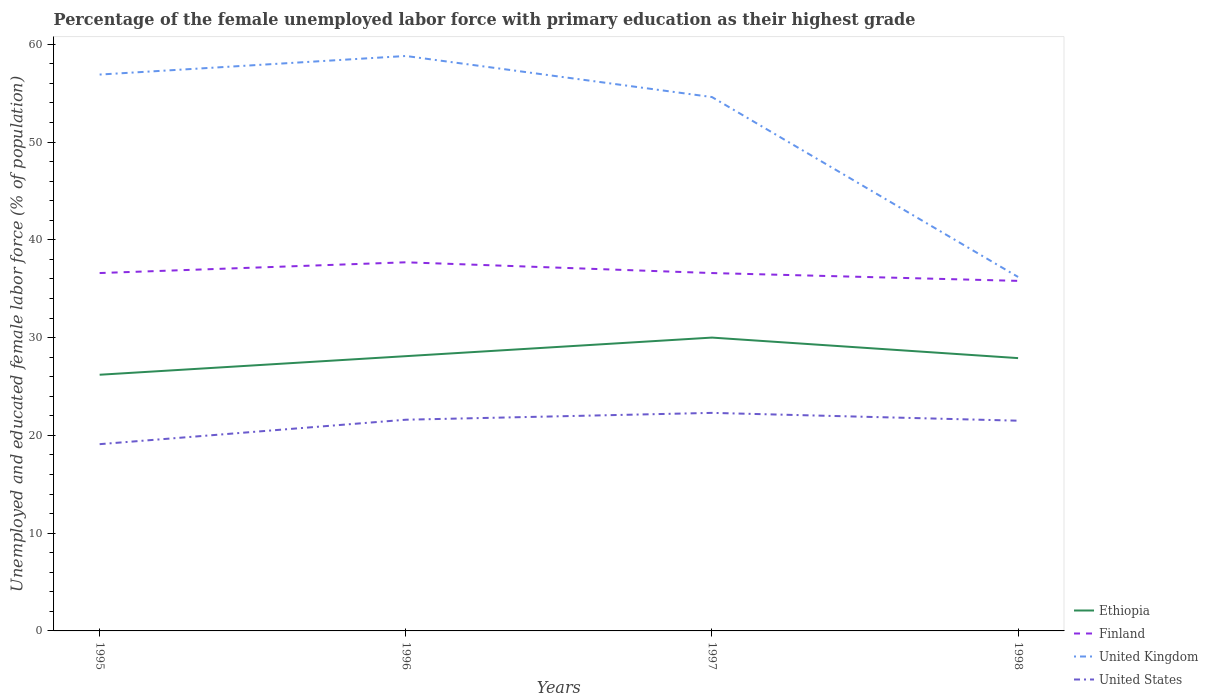How many different coloured lines are there?
Offer a terse response. 4. Across all years, what is the maximum percentage of the unemployed female labor force with primary education in Ethiopia?
Provide a succinct answer. 26.2. In which year was the percentage of the unemployed female labor force with primary education in United States maximum?
Your response must be concise. 1995. What is the total percentage of the unemployed female labor force with primary education in Ethiopia in the graph?
Ensure brevity in your answer.  2.1. What is the difference between the highest and the second highest percentage of the unemployed female labor force with primary education in Ethiopia?
Your answer should be compact. 3.8. What is the difference between the highest and the lowest percentage of the unemployed female labor force with primary education in United Kingdom?
Provide a short and direct response. 3. How many years are there in the graph?
Your response must be concise. 4. What is the difference between two consecutive major ticks on the Y-axis?
Your response must be concise. 10. Does the graph contain any zero values?
Provide a short and direct response. No. Where does the legend appear in the graph?
Offer a terse response. Bottom right. How many legend labels are there?
Offer a very short reply. 4. How are the legend labels stacked?
Your answer should be compact. Vertical. What is the title of the graph?
Offer a very short reply. Percentage of the female unemployed labor force with primary education as their highest grade. Does "Marshall Islands" appear as one of the legend labels in the graph?
Provide a succinct answer. No. What is the label or title of the Y-axis?
Make the answer very short. Unemployed and educated female labor force (% of population). What is the Unemployed and educated female labor force (% of population) of Ethiopia in 1995?
Keep it short and to the point. 26.2. What is the Unemployed and educated female labor force (% of population) in Finland in 1995?
Provide a succinct answer. 36.6. What is the Unemployed and educated female labor force (% of population) in United Kingdom in 1995?
Your answer should be compact. 56.9. What is the Unemployed and educated female labor force (% of population) of United States in 1995?
Give a very brief answer. 19.1. What is the Unemployed and educated female labor force (% of population) of Ethiopia in 1996?
Your response must be concise. 28.1. What is the Unemployed and educated female labor force (% of population) in Finland in 1996?
Provide a succinct answer. 37.7. What is the Unemployed and educated female labor force (% of population) of United Kingdom in 1996?
Make the answer very short. 58.8. What is the Unemployed and educated female labor force (% of population) in United States in 1996?
Make the answer very short. 21.6. What is the Unemployed and educated female labor force (% of population) of Ethiopia in 1997?
Keep it short and to the point. 30. What is the Unemployed and educated female labor force (% of population) in Finland in 1997?
Your answer should be compact. 36.6. What is the Unemployed and educated female labor force (% of population) in United Kingdom in 1997?
Your response must be concise. 54.6. What is the Unemployed and educated female labor force (% of population) of United States in 1997?
Your answer should be very brief. 22.3. What is the Unemployed and educated female labor force (% of population) in Ethiopia in 1998?
Offer a terse response. 27.9. What is the Unemployed and educated female labor force (% of population) in Finland in 1998?
Offer a terse response. 35.8. What is the Unemployed and educated female labor force (% of population) of United Kingdom in 1998?
Your response must be concise. 36.2. What is the Unemployed and educated female labor force (% of population) in United States in 1998?
Your answer should be very brief. 21.5. Across all years, what is the maximum Unemployed and educated female labor force (% of population) of Finland?
Your response must be concise. 37.7. Across all years, what is the maximum Unemployed and educated female labor force (% of population) in United Kingdom?
Provide a succinct answer. 58.8. Across all years, what is the maximum Unemployed and educated female labor force (% of population) of United States?
Offer a very short reply. 22.3. Across all years, what is the minimum Unemployed and educated female labor force (% of population) of Ethiopia?
Make the answer very short. 26.2. Across all years, what is the minimum Unemployed and educated female labor force (% of population) in Finland?
Offer a terse response. 35.8. Across all years, what is the minimum Unemployed and educated female labor force (% of population) in United Kingdom?
Provide a short and direct response. 36.2. Across all years, what is the minimum Unemployed and educated female labor force (% of population) of United States?
Offer a terse response. 19.1. What is the total Unemployed and educated female labor force (% of population) in Ethiopia in the graph?
Your answer should be very brief. 112.2. What is the total Unemployed and educated female labor force (% of population) in Finland in the graph?
Keep it short and to the point. 146.7. What is the total Unemployed and educated female labor force (% of population) in United Kingdom in the graph?
Offer a terse response. 206.5. What is the total Unemployed and educated female labor force (% of population) in United States in the graph?
Offer a very short reply. 84.5. What is the difference between the Unemployed and educated female labor force (% of population) in Ethiopia in 1995 and that in 1996?
Give a very brief answer. -1.9. What is the difference between the Unemployed and educated female labor force (% of population) of United Kingdom in 1995 and that in 1997?
Offer a terse response. 2.3. What is the difference between the Unemployed and educated female labor force (% of population) in Ethiopia in 1995 and that in 1998?
Offer a terse response. -1.7. What is the difference between the Unemployed and educated female labor force (% of population) in United Kingdom in 1995 and that in 1998?
Offer a very short reply. 20.7. What is the difference between the Unemployed and educated female labor force (% of population) of Ethiopia in 1996 and that in 1997?
Your answer should be compact. -1.9. What is the difference between the Unemployed and educated female labor force (% of population) in United Kingdom in 1996 and that in 1997?
Make the answer very short. 4.2. What is the difference between the Unemployed and educated female labor force (% of population) in Ethiopia in 1996 and that in 1998?
Your response must be concise. 0.2. What is the difference between the Unemployed and educated female labor force (% of population) of United Kingdom in 1996 and that in 1998?
Your response must be concise. 22.6. What is the difference between the Unemployed and educated female labor force (% of population) of United States in 1996 and that in 1998?
Give a very brief answer. 0.1. What is the difference between the Unemployed and educated female labor force (% of population) in Ethiopia in 1997 and that in 1998?
Offer a very short reply. 2.1. What is the difference between the Unemployed and educated female labor force (% of population) of United States in 1997 and that in 1998?
Ensure brevity in your answer.  0.8. What is the difference between the Unemployed and educated female labor force (% of population) in Ethiopia in 1995 and the Unemployed and educated female labor force (% of population) in Finland in 1996?
Provide a short and direct response. -11.5. What is the difference between the Unemployed and educated female labor force (% of population) in Ethiopia in 1995 and the Unemployed and educated female labor force (% of population) in United Kingdom in 1996?
Ensure brevity in your answer.  -32.6. What is the difference between the Unemployed and educated female labor force (% of population) of Finland in 1995 and the Unemployed and educated female labor force (% of population) of United Kingdom in 1996?
Your answer should be compact. -22.2. What is the difference between the Unemployed and educated female labor force (% of population) in United Kingdom in 1995 and the Unemployed and educated female labor force (% of population) in United States in 1996?
Keep it short and to the point. 35.3. What is the difference between the Unemployed and educated female labor force (% of population) in Ethiopia in 1995 and the Unemployed and educated female labor force (% of population) in Finland in 1997?
Give a very brief answer. -10.4. What is the difference between the Unemployed and educated female labor force (% of population) of Ethiopia in 1995 and the Unemployed and educated female labor force (% of population) of United Kingdom in 1997?
Your response must be concise. -28.4. What is the difference between the Unemployed and educated female labor force (% of population) of Ethiopia in 1995 and the Unemployed and educated female labor force (% of population) of United States in 1997?
Keep it short and to the point. 3.9. What is the difference between the Unemployed and educated female labor force (% of population) in Finland in 1995 and the Unemployed and educated female labor force (% of population) in United Kingdom in 1997?
Your response must be concise. -18. What is the difference between the Unemployed and educated female labor force (% of population) of United Kingdom in 1995 and the Unemployed and educated female labor force (% of population) of United States in 1997?
Provide a short and direct response. 34.6. What is the difference between the Unemployed and educated female labor force (% of population) of Ethiopia in 1995 and the Unemployed and educated female labor force (% of population) of Finland in 1998?
Ensure brevity in your answer.  -9.6. What is the difference between the Unemployed and educated female labor force (% of population) in Ethiopia in 1995 and the Unemployed and educated female labor force (% of population) in United Kingdom in 1998?
Offer a very short reply. -10. What is the difference between the Unemployed and educated female labor force (% of population) of Ethiopia in 1995 and the Unemployed and educated female labor force (% of population) of United States in 1998?
Offer a very short reply. 4.7. What is the difference between the Unemployed and educated female labor force (% of population) in Finland in 1995 and the Unemployed and educated female labor force (% of population) in United States in 1998?
Provide a succinct answer. 15.1. What is the difference between the Unemployed and educated female labor force (% of population) of United Kingdom in 1995 and the Unemployed and educated female labor force (% of population) of United States in 1998?
Offer a very short reply. 35.4. What is the difference between the Unemployed and educated female labor force (% of population) in Ethiopia in 1996 and the Unemployed and educated female labor force (% of population) in Finland in 1997?
Offer a terse response. -8.5. What is the difference between the Unemployed and educated female labor force (% of population) of Ethiopia in 1996 and the Unemployed and educated female labor force (% of population) of United Kingdom in 1997?
Provide a short and direct response. -26.5. What is the difference between the Unemployed and educated female labor force (% of population) of Ethiopia in 1996 and the Unemployed and educated female labor force (% of population) of United States in 1997?
Make the answer very short. 5.8. What is the difference between the Unemployed and educated female labor force (% of population) of Finland in 1996 and the Unemployed and educated female labor force (% of population) of United Kingdom in 1997?
Keep it short and to the point. -16.9. What is the difference between the Unemployed and educated female labor force (% of population) in United Kingdom in 1996 and the Unemployed and educated female labor force (% of population) in United States in 1997?
Give a very brief answer. 36.5. What is the difference between the Unemployed and educated female labor force (% of population) in Ethiopia in 1996 and the Unemployed and educated female labor force (% of population) in Finland in 1998?
Provide a succinct answer. -7.7. What is the difference between the Unemployed and educated female labor force (% of population) of Ethiopia in 1996 and the Unemployed and educated female labor force (% of population) of United Kingdom in 1998?
Give a very brief answer. -8.1. What is the difference between the Unemployed and educated female labor force (% of population) of United Kingdom in 1996 and the Unemployed and educated female labor force (% of population) of United States in 1998?
Your answer should be compact. 37.3. What is the difference between the Unemployed and educated female labor force (% of population) of Ethiopia in 1997 and the Unemployed and educated female labor force (% of population) of United Kingdom in 1998?
Your answer should be very brief. -6.2. What is the difference between the Unemployed and educated female labor force (% of population) in Ethiopia in 1997 and the Unemployed and educated female labor force (% of population) in United States in 1998?
Offer a very short reply. 8.5. What is the difference between the Unemployed and educated female labor force (% of population) of Finland in 1997 and the Unemployed and educated female labor force (% of population) of United States in 1998?
Ensure brevity in your answer.  15.1. What is the difference between the Unemployed and educated female labor force (% of population) of United Kingdom in 1997 and the Unemployed and educated female labor force (% of population) of United States in 1998?
Provide a short and direct response. 33.1. What is the average Unemployed and educated female labor force (% of population) in Ethiopia per year?
Give a very brief answer. 28.05. What is the average Unemployed and educated female labor force (% of population) in Finland per year?
Keep it short and to the point. 36.67. What is the average Unemployed and educated female labor force (% of population) of United Kingdom per year?
Ensure brevity in your answer.  51.62. What is the average Unemployed and educated female labor force (% of population) of United States per year?
Offer a terse response. 21.12. In the year 1995, what is the difference between the Unemployed and educated female labor force (% of population) of Ethiopia and Unemployed and educated female labor force (% of population) of Finland?
Your response must be concise. -10.4. In the year 1995, what is the difference between the Unemployed and educated female labor force (% of population) of Ethiopia and Unemployed and educated female labor force (% of population) of United Kingdom?
Ensure brevity in your answer.  -30.7. In the year 1995, what is the difference between the Unemployed and educated female labor force (% of population) in Ethiopia and Unemployed and educated female labor force (% of population) in United States?
Provide a succinct answer. 7.1. In the year 1995, what is the difference between the Unemployed and educated female labor force (% of population) in Finland and Unemployed and educated female labor force (% of population) in United Kingdom?
Give a very brief answer. -20.3. In the year 1995, what is the difference between the Unemployed and educated female labor force (% of population) in Finland and Unemployed and educated female labor force (% of population) in United States?
Ensure brevity in your answer.  17.5. In the year 1995, what is the difference between the Unemployed and educated female labor force (% of population) in United Kingdom and Unemployed and educated female labor force (% of population) in United States?
Ensure brevity in your answer.  37.8. In the year 1996, what is the difference between the Unemployed and educated female labor force (% of population) of Ethiopia and Unemployed and educated female labor force (% of population) of United Kingdom?
Make the answer very short. -30.7. In the year 1996, what is the difference between the Unemployed and educated female labor force (% of population) of Finland and Unemployed and educated female labor force (% of population) of United Kingdom?
Keep it short and to the point. -21.1. In the year 1996, what is the difference between the Unemployed and educated female labor force (% of population) of Finland and Unemployed and educated female labor force (% of population) of United States?
Provide a succinct answer. 16.1. In the year 1996, what is the difference between the Unemployed and educated female labor force (% of population) in United Kingdom and Unemployed and educated female labor force (% of population) in United States?
Offer a very short reply. 37.2. In the year 1997, what is the difference between the Unemployed and educated female labor force (% of population) of Ethiopia and Unemployed and educated female labor force (% of population) of Finland?
Your answer should be compact. -6.6. In the year 1997, what is the difference between the Unemployed and educated female labor force (% of population) in Ethiopia and Unemployed and educated female labor force (% of population) in United Kingdom?
Provide a succinct answer. -24.6. In the year 1997, what is the difference between the Unemployed and educated female labor force (% of population) of Finland and Unemployed and educated female labor force (% of population) of United Kingdom?
Make the answer very short. -18. In the year 1997, what is the difference between the Unemployed and educated female labor force (% of population) of United Kingdom and Unemployed and educated female labor force (% of population) of United States?
Make the answer very short. 32.3. In the year 1998, what is the difference between the Unemployed and educated female labor force (% of population) of Ethiopia and Unemployed and educated female labor force (% of population) of United Kingdom?
Make the answer very short. -8.3. In the year 1998, what is the difference between the Unemployed and educated female labor force (% of population) in Ethiopia and Unemployed and educated female labor force (% of population) in United States?
Give a very brief answer. 6.4. In the year 1998, what is the difference between the Unemployed and educated female labor force (% of population) in Finland and Unemployed and educated female labor force (% of population) in United Kingdom?
Provide a short and direct response. -0.4. In the year 1998, what is the difference between the Unemployed and educated female labor force (% of population) in United Kingdom and Unemployed and educated female labor force (% of population) in United States?
Make the answer very short. 14.7. What is the ratio of the Unemployed and educated female labor force (% of population) in Ethiopia in 1995 to that in 1996?
Your answer should be compact. 0.93. What is the ratio of the Unemployed and educated female labor force (% of population) of Finland in 1995 to that in 1996?
Your answer should be compact. 0.97. What is the ratio of the Unemployed and educated female labor force (% of population) in United Kingdom in 1995 to that in 1996?
Give a very brief answer. 0.97. What is the ratio of the Unemployed and educated female labor force (% of population) of United States in 1995 to that in 1996?
Offer a terse response. 0.88. What is the ratio of the Unemployed and educated female labor force (% of population) of Ethiopia in 1995 to that in 1997?
Your response must be concise. 0.87. What is the ratio of the Unemployed and educated female labor force (% of population) of United Kingdom in 1995 to that in 1997?
Offer a very short reply. 1.04. What is the ratio of the Unemployed and educated female labor force (% of population) in United States in 1995 to that in 1997?
Provide a succinct answer. 0.86. What is the ratio of the Unemployed and educated female labor force (% of population) in Ethiopia in 1995 to that in 1998?
Keep it short and to the point. 0.94. What is the ratio of the Unemployed and educated female labor force (% of population) in Finland in 1995 to that in 1998?
Provide a short and direct response. 1.02. What is the ratio of the Unemployed and educated female labor force (% of population) of United Kingdom in 1995 to that in 1998?
Your answer should be compact. 1.57. What is the ratio of the Unemployed and educated female labor force (% of population) in United States in 1995 to that in 1998?
Your response must be concise. 0.89. What is the ratio of the Unemployed and educated female labor force (% of population) of Ethiopia in 1996 to that in 1997?
Give a very brief answer. 0.94. What is the ratio of the Unemployed and educated female labor force (% of population) of Finland in 1996 to that in 1997?
Your answer should be very brief. 1.03. What is the ratio of the Unemployed and educated female labor force (% of population) in United Kingdom in 1996 to that in 1997?
Your answer should be compact. 1.08. What is the ratio of the Unemployed and educated female labor force (% of population) in United States in 1996 to that in 1997?
Your answer should be compact. 0.97. What is the ratio of the Unemployed and educated female labor force (% of population) of Ethiopia in 1996 to that in 1998?
Ensure brevity in your answer.  1.01. What is the ratio of the Unemployed and educated female labor force (% of population) of Finland in 1996 to that in 1998?
Provide a short and direct response. 1.05. What is the ratio of the Unemployed and educated female labor force (% of population) in United Kingdom in 1996 to that in 1998?
Provide a short and direct response. 1.62. What is the ratio of the Unemployed and educated female labor force (% of population) of United States in 1996 to that in 1998?
Ensure brevity in your answer.  1. What is the ratio of the Unemployed and educated female labor force (% of population) of Ethiopia in 1997 to that in 1998?
Your answer should be compact. 1.08. What is the ratio of the Unemployed and educated female labor force (% of population) in Finland in 1997 to that in 1998?
Offer a terse response. 1.02. What is the ratio of the Unemployed and educated female labor force (% of population) of United Kingdom in 1997 to that in 1998?
Provide a short and direct response. 1.51. What is the ratio of the Unemployed and educated female labor force (% of population) of United States in 1997 to that in 1998?
Make the answer very short. 1.04. What is the difference between the highest and the second highest Unemployed and educated female labor force (% of population) of Finland?
Ensure brevity in your answer.  1.1. What is the difference between the highest and the second highest Unemployed and educated female labor force (% of population) of United Kingdom?
Ensure brevity in your answer.  1.9. What is the difference between the highest and the second highest Unemployed and educated female labor force (% of population) in United States?
Your response must be concise. 0.7. What is the difference between the highest and the lowest Unemployed and educated female labor force (% of population) of Ethiopia?
Make the answer very short. 3.8. What is the difference between the highest and the lowest Unemployed and educated female labor force (% of population) of Finland?
Keep it short and to the point. 1.9. What is the difference between the highest and the lowest Unemployed and educated female labor force (% of population) in United Kingdom?
Offer a very short reply. 22.6. What is the difference between the highest and the lowest Unemployed and educated female labor force (% of population) in United States?
Your response must be concise. 3.2. 